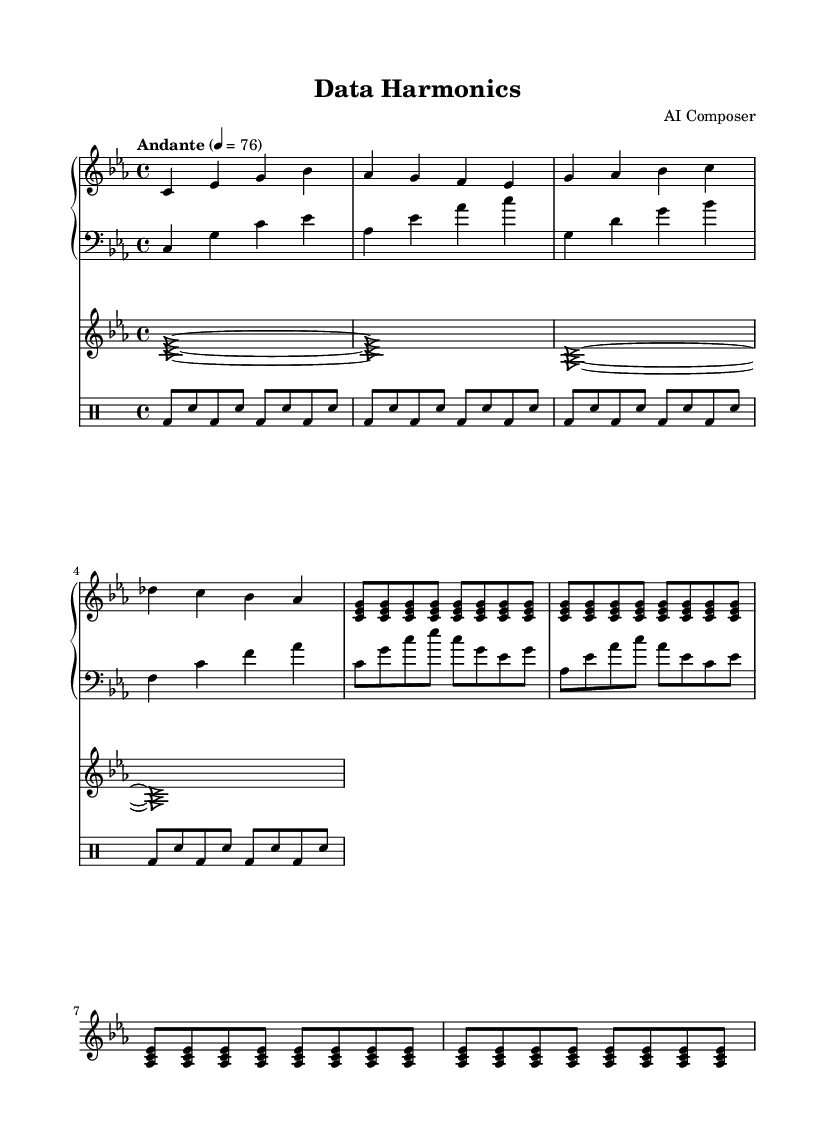What is the key signature of this music? The key signature is C minor, which has three flats: B flat, E flat, and A flat.
Answer: C minor What is the time signature of this piece? The time signature is indicated in the top left and shows a 4 over 4, which means there are four beats in each measure and a quarter note gets one beat.
Answer: 4/4 What is the tempo marking for this composition? The tempo marking is specified as "Andante," which generally indicates a moderately slow tempo. The metronome speed is also given as 76 beats per minute.
Answer: Andante How many measures are there in the right hand part? By counting the grouping of notes in the right hand section, there are a total of 8 measures present.
Answer: 8 What distinguishes the synthesizer pads from the piano parts? The synthesizer pads are represented with triangular note heads, differentiating them visually from the round note heads of the piano parts, and they play longer sustained notes compared to the piano's shorter, more rhythmic figures.
Answer: Triangular note heads What rhythmic pattern is consistently used in the electronic percussion part? The electronic percussion consists of a repeated pattern of bass drum and snare hits (bd and sn), specifically using eighth notes throughout the section, which creates a driving rhythm.
Answer: Bass drum and snare 